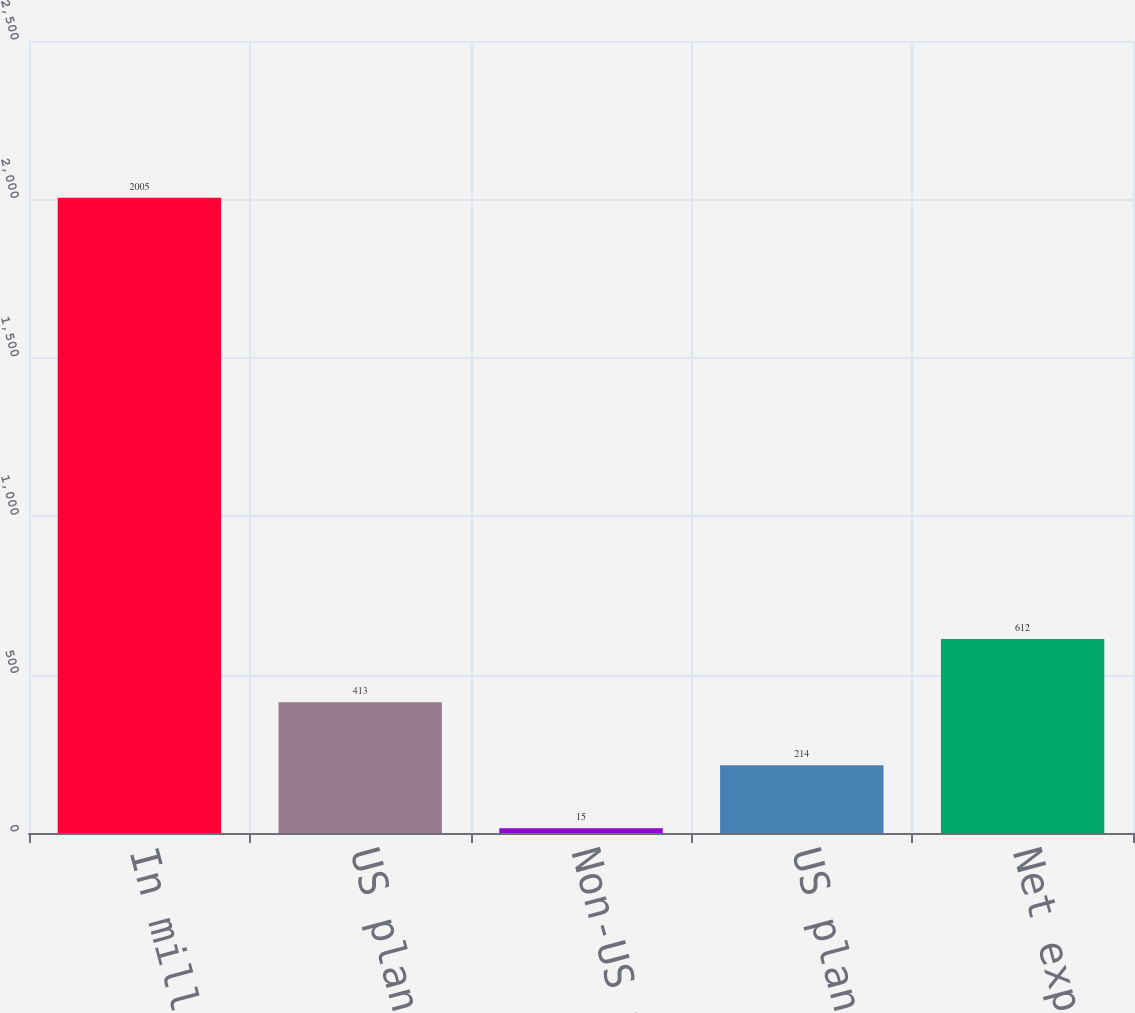Convert chart to OTSL. <chart><loc_0><loc_0><loc_500><loc_500><bar_chart><fcel>In millions<fcel>US plans (non-cash)<fcel>Non-US plans<fcel>US plans<fcel>Net expense<nl><fcel>2005<fcel>413<fcel>15<fcel>214<fcel>612<nl></chart> 